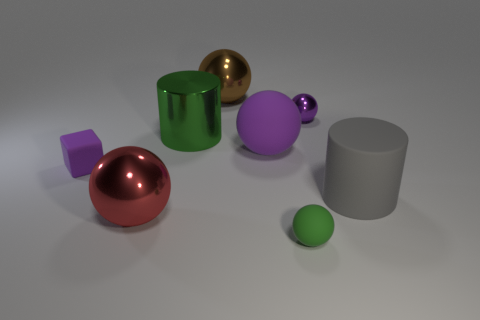Add 1 yellow shiny things. How many objects exist? 9 Subtract all purple matte spheres. How many spheres are left? 4 Subtract all cubes. How many objects are left? 7 Subtract all green cylinders. How many cylinders are left? 1 Subtract 1 brown spheres. How many objects are left? 7 Subtract 3 balls. How many balls are left? 2 Subtract all cyan spheres. Subtract all blue cylinders. How many spheres are left? 5 Subtract all cyan cylinders. How many cyan blocks are left? 0 Subtract all tiny purple things. Subtract all tiny brown things. How many objects are left? 6 Add 7 small green matte balls. How many small green matte balls are left? 8 